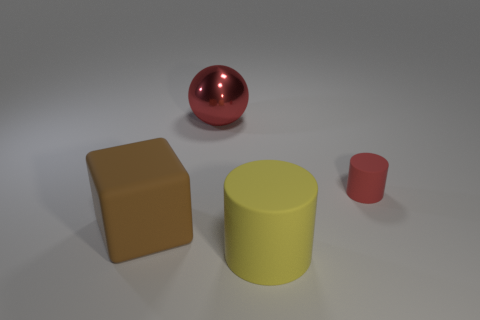Subtract all yellow cylinders. How many cylinders are left? 1 Subtract all cubes. How many objects are left? 3 Subtract 1 spheres. How many spheres are left? 0 Add 2 yellow rubber things. How many objects exist? 6 Subtract all brown spheres. Subtract all blue cylinders. How many spheres are left? 1 Subtract all red cylinders. How many gray balls are left? 0 Subtract all big matte cubes. Subtract all yellow rubber cubes. How many objects are left? 3 Add 2 big spheres. How many big spheres are left? 3 Add 2 blue matte things. How many blue matte things exist? 2 Subtract 0 yellow balls. How many objects are left? 4 